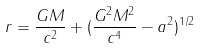<formula> <loc_0><loc_0><loc_500><loc_500>r = \frac { G M } { c ^ { 2 } } + ( \frac { G ^ { 2 } M ^ { 2 } } { c ^ { 4 } } - a ^ { 2 } ) ^ { 1 / 2 }</formula> 